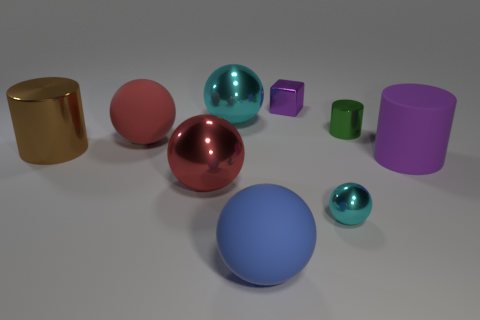Subtract all small shiny spheres. How many spheres are left? 4 Subtract all blue balls. How many balls are left? 4 Subtract all green balls. Subtract all red cubes. How many balls are left? 5 Subtract all cubes. How many objects are left? 8 Add 9 large green cylinders. How many large green cylinders exist? 9 Subtract 0 brown cubes. How many objects are left? 9 Subtract all big blue matte things. Subtract all big purple matte cylinders. How many objects are left? 7 Add 3 tiny shiny things. How many tiny shiny things are left? 6 